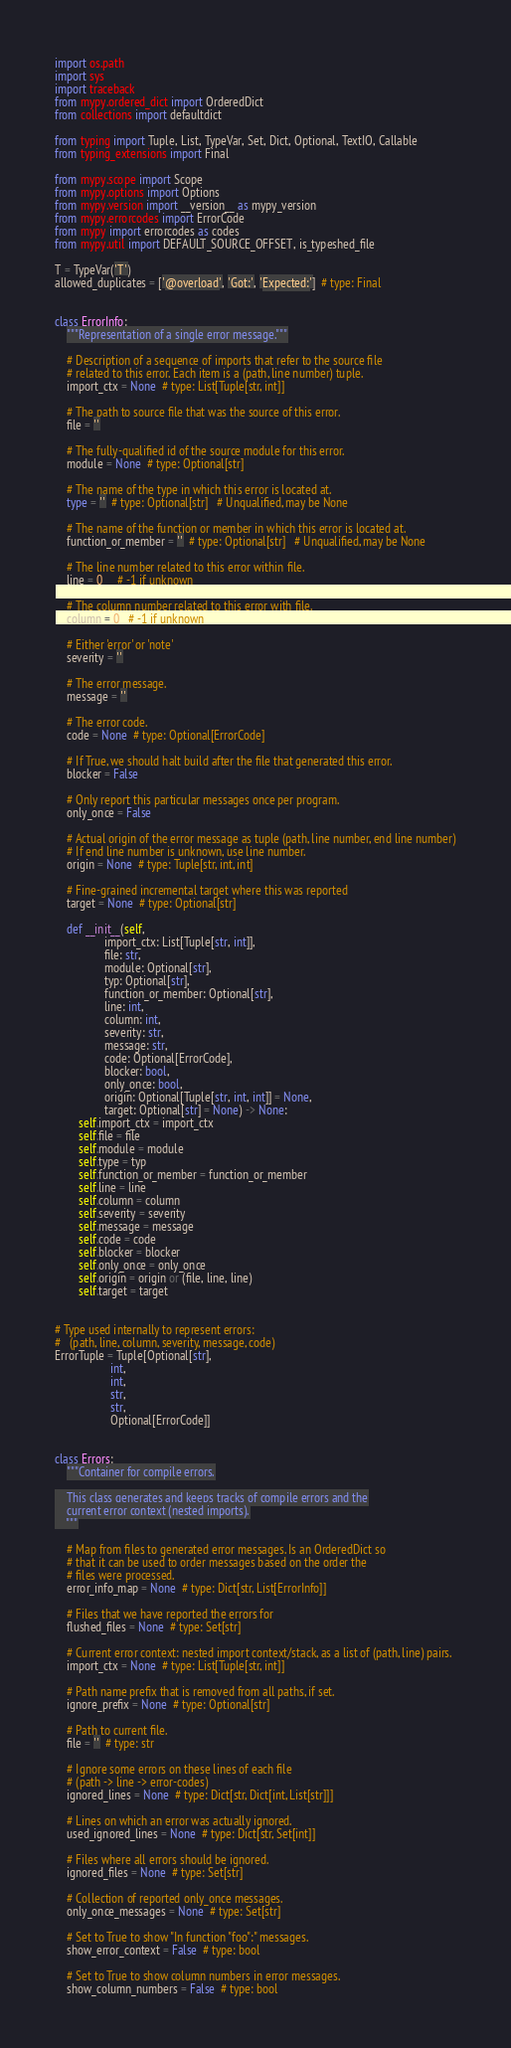Convert code to text. <code><loc_0><loc_0><loc_500><loc_500><_Python_>import os.path
import sys
import traceback
from mypy.ordered_dict import OrderedDict
from collections import defaultdict

from typing import Tuple, List, TypeVar, Set, Dict, Optional, TextIO, Callable
from typing_extensions import Final

from mypy.scope import Scope
from mypy.options import Options
from mypy.version import __version__ as mypy_version
from mypy.errorcodes import ErrorCode
from mypy import errorcodes as codes
from mypy.util import DEFAULT_SOURCE_OFFSET, is_typeshed_file

T = TypeVar('T')
allowed_duplicates = ['@overload', 'Got:', 'Expected:']  # type: Final


class ErrorInfo:
    """Representation of a single error message."""

    # Description of a sequence of imports that refer to the source file
    # related to this error. Each item is a (path, line number) tuple.
    import_ctx = None  # type: List[Tuple[str, int]]

    # The path to source file that was the source of this error.
    file = ''

    # The fully-qualified id of the source module for this error.
    module = None  # type: Optional[str]

    # The name of the type in which this error is located at.
    type = ''  # type: Optional[str]   # Unqualified, may be None

    # The name of the function or member in which this error is located at.
    function_or_member = ''  # type: Optional[str]   # Unqualified, may be None

    # The line number related to this error within file.
    line = 0     # -1 if unknown

    # The column number related to this error with file.
    column = 0   # -1 if unknown

    # Either 'error' or 'note'
    severity = ''

    # The error message.
    message = ''

    # The error code.
    code = None  # type: Optional[ErrorCode]

    # If True, we should halt build after the file that generated this error.
    blocker = False

    # Only report this particular messages once per program.
    only_once = False

    # Actual origin of the error message as tuple (path, line number, end line number)
    # If end line number is unknown, use line number.
    origin = None  # type: Tuple[str, int, int]

    # Fine-grained incremental target where this was reported
    target = None  # type: Optional[str]

    def __init__(self,
                 import_ctx: List[Tuple[str, int]],
                 file: str,
                 module: Optional[str],
                 typ: Optional[str],
                 function_or_member: Optional[str],
                 line: int,
                 column: int,
                 severity: str,
                 message: str,
                 code: Optional[ErrorCode],
                 blocker: bool,
                 only_once: bool,
                 origin: Optional[Tuple[str, int, int]] = None,
                 target: Optional[str] = None) -> None:
        self.import_ctx = import_ctx
        self.file = file
        self.module = module
        self.type = typ
        self.function_or_member = function_or_member
        self.line = line
        self.column = column
        self.severity = severity
        self.message = message
        self.code = code
        self.blocker = blocker
        self.only_once = only_once
        self.origin = origin or (file, line, line)
        self.target = target


# Type used internally to represent errors:
#   (path, line, column, severity, message, code)
ErrorTuple = Tuple[Optional[str],
                   int,
                   int,
                   str,
                   str,
                   Optional[ErrorCode]]


class Errors:
    """Container for compile errors.

    This class generates and keeps tracks of compile errors and the
    current error context (nested imports).
    """

    # Map from files to generated error messages. Is an OrderedDict so
    # that it can be used to order messages based on the order the
    # files were processed.
    error_info_map = None  # type: Dict[str, List[ErrorInfo]]

    # Files that we have reported the errors for
    flushed_files = None  # type: Set[str]

    # Current error context: nested import context/stack, as a list of (path, line) pairs.
    import_ctx = None  # type: List[Tuple[str, int]]

    # Path name prefix that is removed from all paths, if set.
    ignore_prefix = None  # type: Optional[str]

    # Path to current file.
    file = ''  # type: str

    # Ignore some errors on these lines of each file
    # (path -> line -> error-codes)
    ignored_lines = None  # type: Dict[str, Dict[int, List[str]]]

    # Lines on which an error was actually ignored.
    used_ignored_lines = None  # type: Dict[str, Set[int]]

    # Files where all errors should be ignored.
    ignored_files = None  # type: Set[str]

    # Collection of reported only_once messages.
    only_once_messages = None  # type: Set[str]

    # Set to True to show "In function "foo":" messages.
    show_error_context = False  # type: bool

    # Set to True to show column numbers in error messages.
    show_column_numbers = False  # type: bool
</code> 